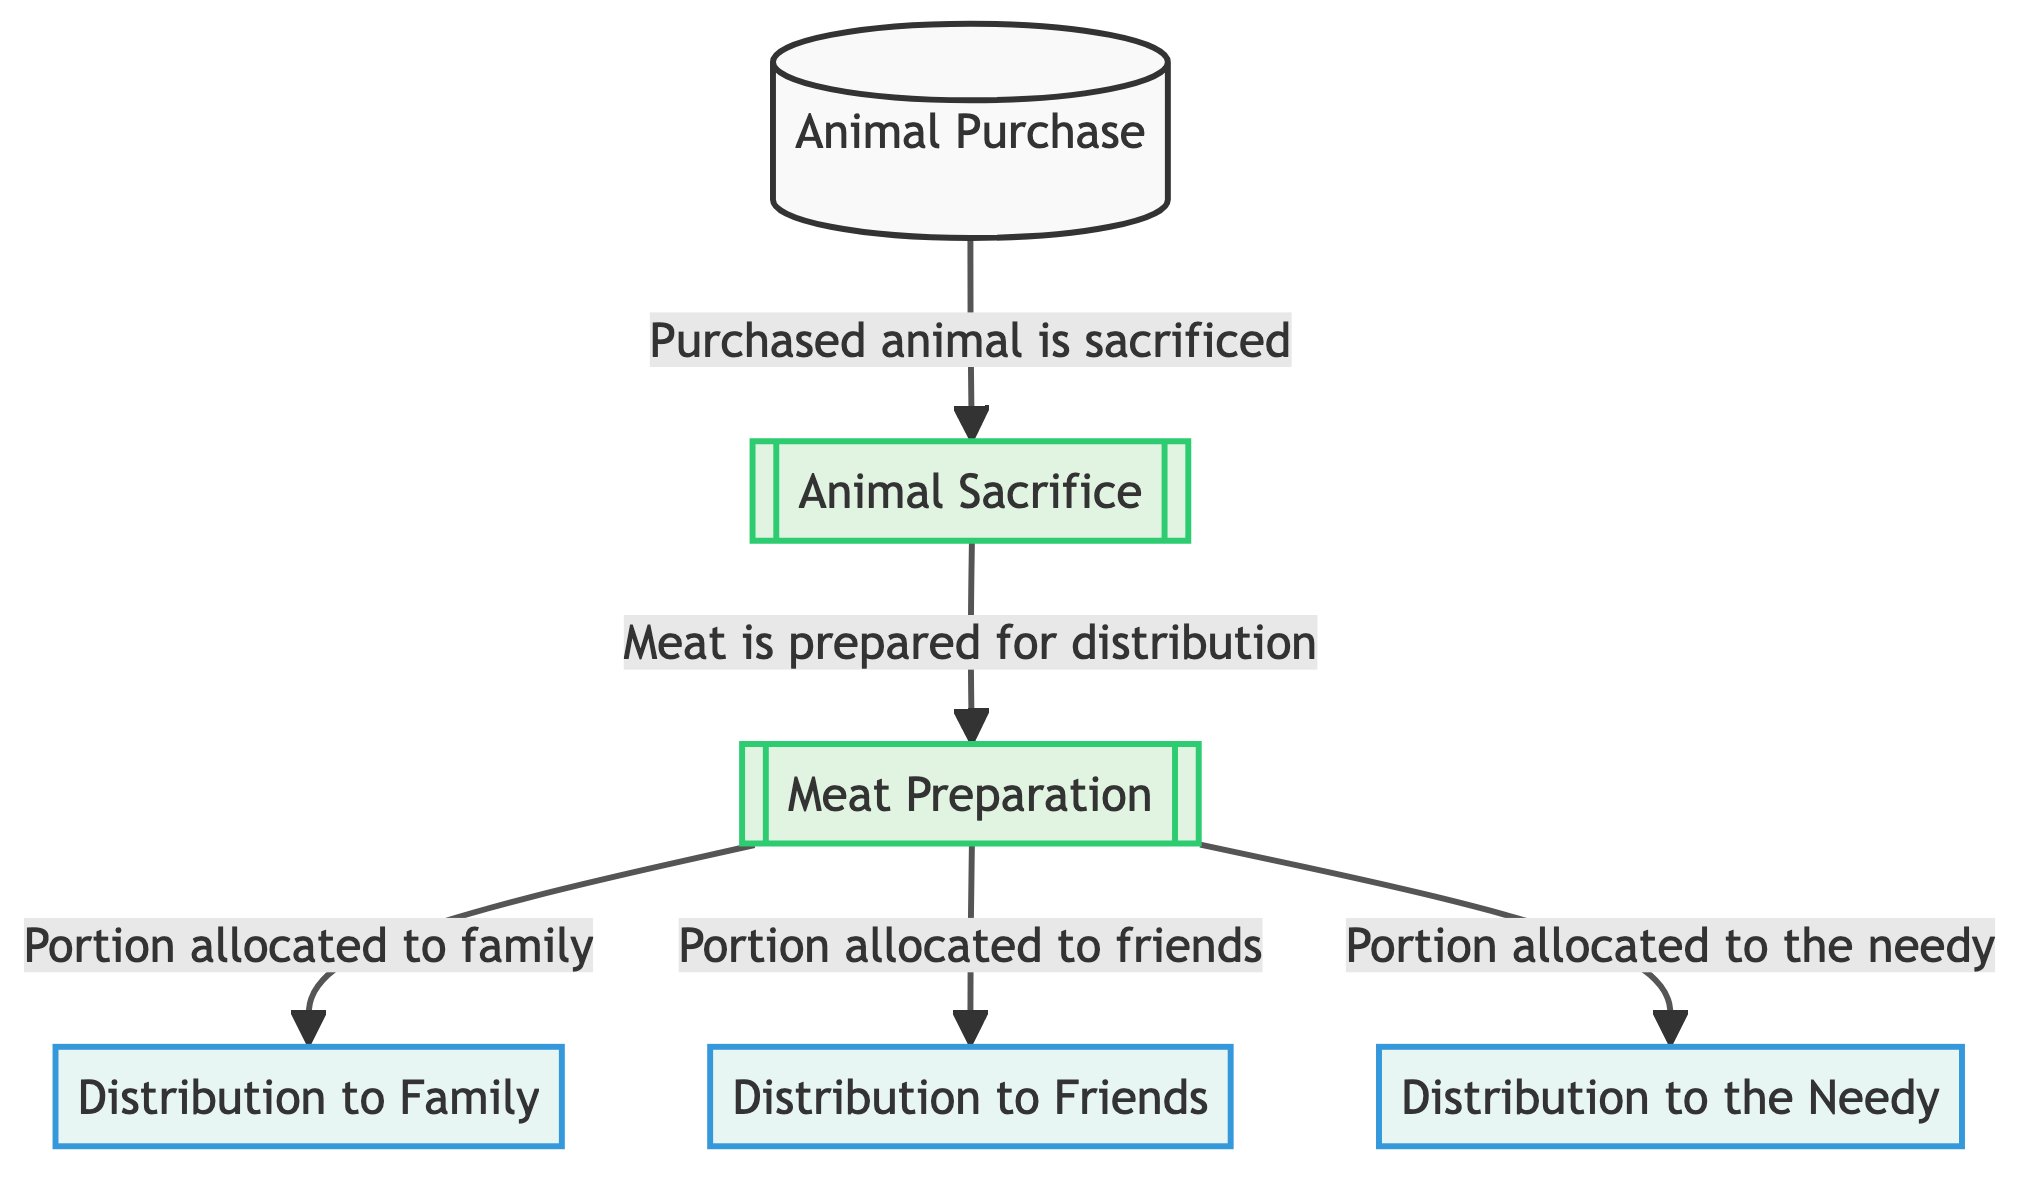What is the first step in the chain? The first step in the chain is the "Animal Purchase," as indicated at the beginning of the flowchart. It is visually represented as the first node in the ordered process.
Answer: Animal Purchase How many distribution points are there? The diagram shows a total of three distribution points: "Distribution to Family," "Distribution to Friends," and "Distribution to the Needy." Counting these nodes gives the total number.
Answer: 3 What happens after the animal is sacrificed? After the animal is sacrificed, the next step is "Meat Preparation," as indicated in the flow of the diagram, linking the sacrifice directly to the meat preparation process.
Answer: Meat Preparation What is allocated to family after meat preparation? After meat preparation, a "Portion allocated to family" is defined in the distribution flow, indicating that part of the meat is specifically set aside for family members.
Answer: Portion allocated to family Which two groups receive meat before the needy? The flowchart indicates that "Distribution to Friends" and "Distribution to Family" are both allocated portions of meat before any distribution to the needy occurs, showing their priority in the distribution chain.
Answer: Friends and Family What is the purpose of the distribution nodes? The purpose of the distribution nodes is to show where the prepared meat is allocated after preparation, specifying to whom the meat is distributed: family, friends, and the needy. This is illustrated in the diagram through these distinct nodes.
Answer: To allocate prepared meat Which node shows the end of the process? The end of the process is represented by the "Distribution to the Needy" node, as there are no further steps or links beyond this, marking it as the final destination of the flow.
Answer: Distribution to the Needy What connects the animal sacrifice to meat preparation? The connection from "Animal Sacrifice" to "Meat Preparation" is established by the step that indicates the meat is prepared after the sacrifice, shown by the directed arrow leading from one to the other in the diagram.
Answer: Meat is prepared for distribution How many steps are there after the animal purchase? After the animal purchase, there are three subsequent steps: animal sacrifice, meat preparation, and then three distribution points. Counting these steps from the purchase node gives the total number.
Answer: 5 